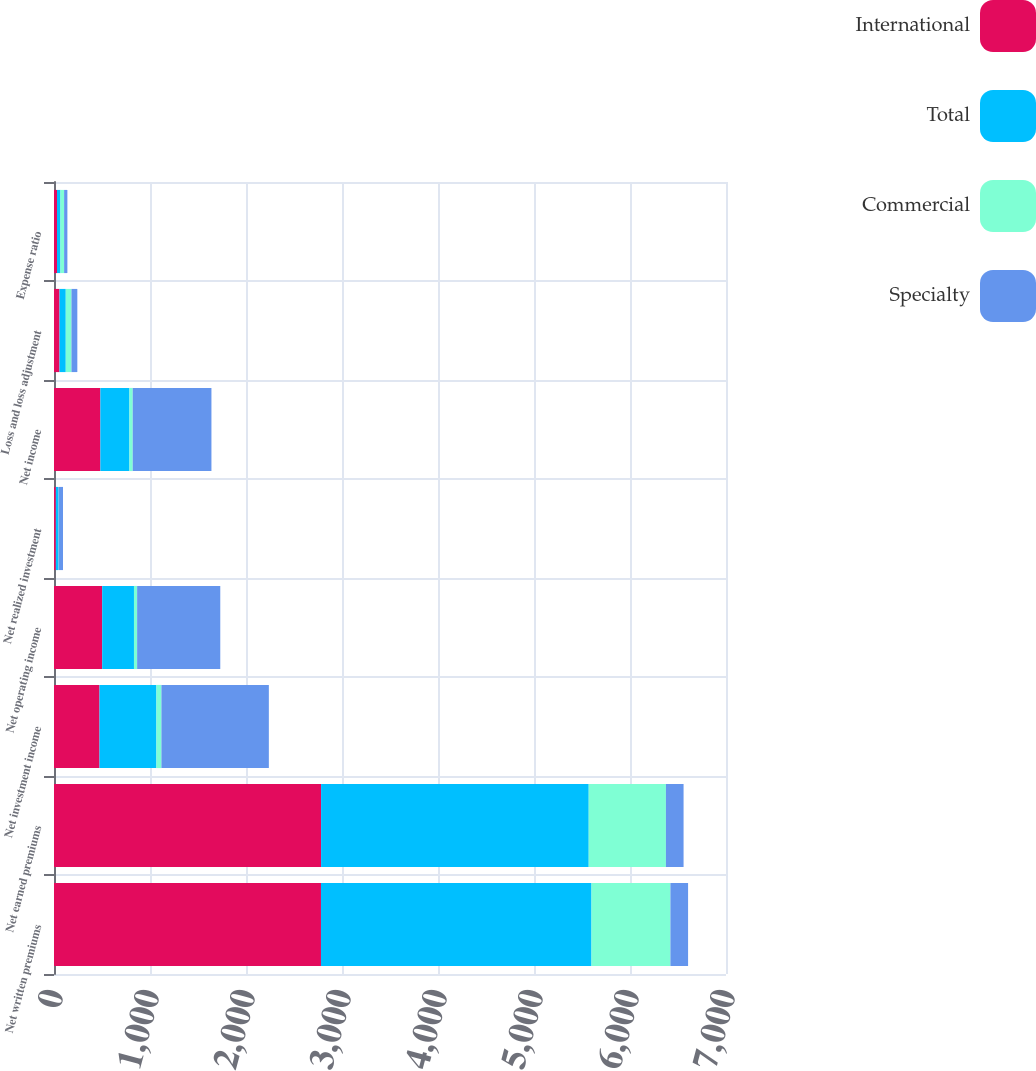Convert chart to OTSL. <chart><loc_0><loc_0><loc_500><loc_500><stacked_bar_chart><ecel><fcel>Net written premiums<fcel>Net earned premiums<fcel>Net investment income<fcel>Net operating income<fcel>Net realized investment<fcel>Net income<fcel>Loss and loss adjustment<fcel>Expense ratio<nl><fcel>International<fcel>2781<fcel>2782<fcel>474<fcel>502<fcel>19<fcel>483<fcel>57.4<fcel>31.1<nl><fcel>Total<fcel>2818<fcel>2788<fcel>593<fcel>331<fcel>28<fcel>303<fcel>65.1<fcel>36.1<nl><fcel>Commercial<fcel>822<fcel>804<fcel>52<fcel>33<fcel>1<fcel>34<fcel>59.5<fcel>38.1<nl><fcel>Specialty<fcel>184.05<fcel>184.05<fcel>1119<fcel>866<fcel>46<fcel>820<fcel>61<fcel>34.2<nl></chart> 